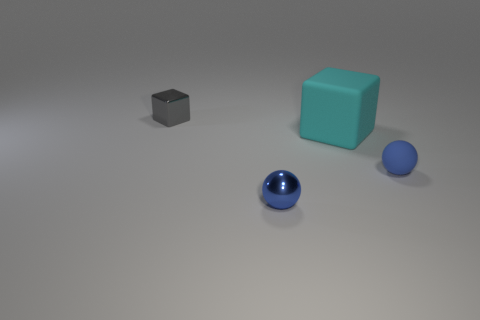Do the small shiny ball and the small matte ball have the same color?
Your answer should be compact. Yes. How many objects are blue balls that are right of the cyan matte object or gray spheres?
Your answer should be compact. 1. What number of gray objects are to the left of the small blue thing to the left of the cyan thing?
Provide a succinct answer. 1. How big is the rubber object that is left of the small blue thing that is right of the cyan thing that is to the right of the gray metallic block?
Keep it short and to the point. Large. Do the tiny shiny object that is in front of the tiny gray shiny block and the small rubber sphere have the same color?
Provide a succinct answer. Yes. There is another object that is the same shape as the gray object; what is its size?
Offer a terse response. Large. How many things are small metal objects that are in front of the big block or blue balls on the left side of the small blue matte object?
Provide a succinct answer. 1. What is the shape of the object on the left side of the metallic thing that is in front of the gray metallic block?
Keep it short and to the point. Cube. Is there anything else that has the same color as the metallic block?
Offer a very short reply. No. Are there any other things that are the same size as the cyan object?
Offer a terse response. No. 